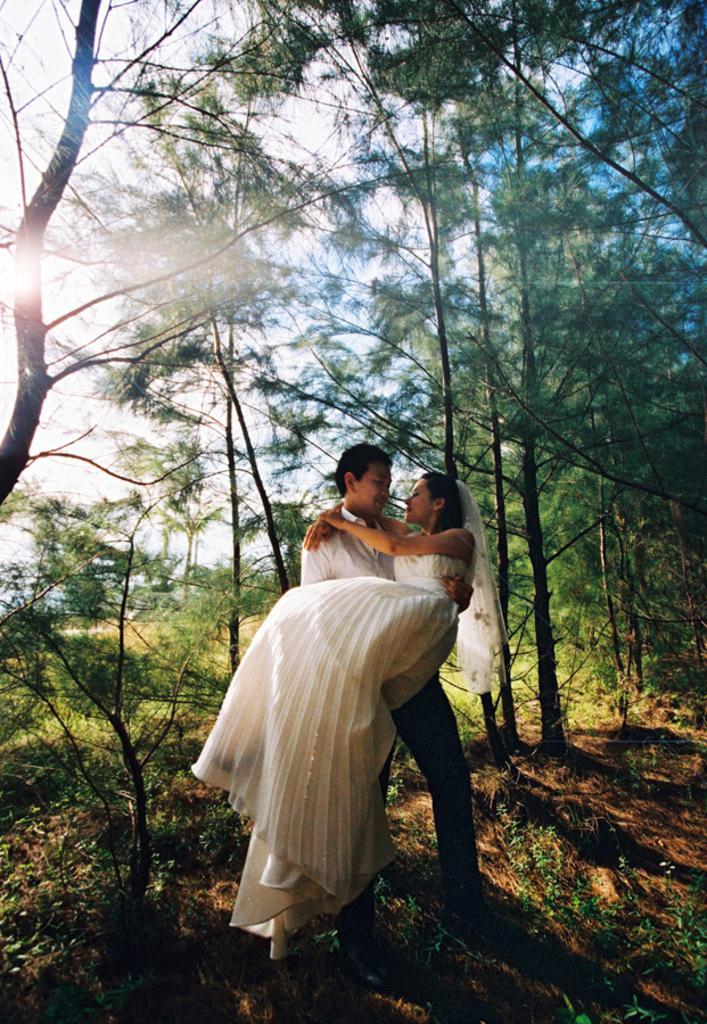Could you give a brief overview of what you see in this image? This is the picture of a place where we have a person who is lifting the lady who is in white gown and behind there are some trees and plants. 